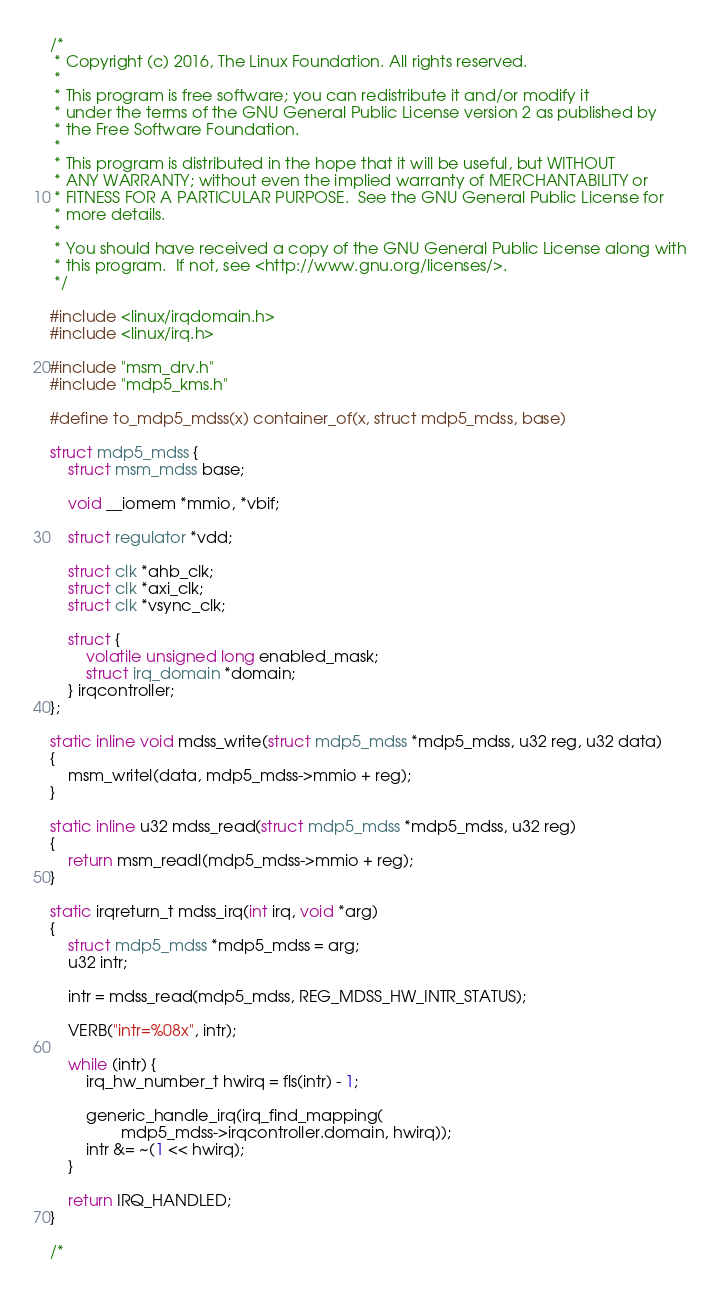<code> <loc_0><loc_0><loc_500><loc_500><_C_>/*
 * Copyright (c) 2016, The Linux Foundation. All rights reserved.
 *
 * This program is free software; you can redistribute it and/or modify it
 * under the terms of the GNU General Public License version 2 as published by
 * the Free Software Foundation.
 *
 * This program is distributed in the hope that it will be useful, but WITHOUT
 * ANY WARRANTY; without even the implied warranty of MERCHANTABILITY or
 * FITNESS FOR A PARTICULAR PURPOSE.  See the GNU General Public License for
 * more details.
 *
 * You should have received a copy of the GNU General Public License along with
 * this program.  If not, see <http://www.gnu.org/licenses/>.
 */

#include <linux/irqdomain.h>
#include <linux/irq.h>

#include "msm_drv.h"
#include "mdp5_kms.h"

#define to_mdp5_mdss(x) container_of(x, struct mdp5_mdss, base)

struct mdp5_mdss {
	struct msm_mdss base;

	void __iomem *mmio, *vbif;

	struct regulator *vdd;

	struct clk *ahb_clk;
	struct clk *axi_clk;
	struct clk *vsync_clk;

	struct {
		volatile unsigned long enabled_mask;
		struct irq_domain *domain;
	} irqcontroller;
};

static inline void mdss_write(struct mdp5_mdss *mdp5_mdss, u32 reg, u32 data)
{
	msm_writel(data, mdp5_mdss->mmio + reg);
}

static inline u32 mdss_read(struct mdp5_mdss *mdp5_mdss, u32 reg)
{
	return msm_readl(mdp5_mdss->mmio + reg);
}

static irqreturn_t mdss_irq(int irq, void *arg)
{
	struct mdp5_mdss *mdp5_mdss = arg;
	u32 intr;

	intr = mdss_read(mdp5_mdss, REG_MDSS_HW_INTR_STATUS);

	VERB("intr=%08x", intr);

	while (intr) {
		irq_hw_number_t hwirq = fls(intr) - 1;

		generic_handle_irq(irq_find_mapping(
				mdp5_mdss->irqcontroller.domain, hwirq));
		intr &= ~(1 << hwirq);
	}

	return IRQ_HANDLED;
}

/*</code> 